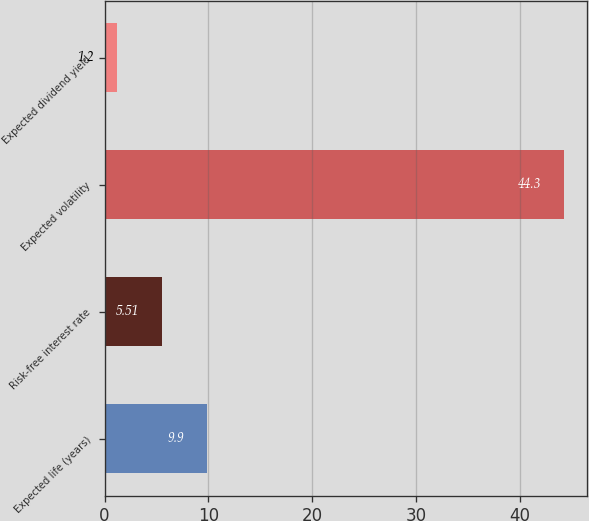Convert chart. <chart><loc_0><loc_0><loc_500><loc_500><bar_chart><fcel>Expected life (years)<fcel>Risk-free interest rate<fcel>Expected volatility<fcel>Expected dividend yield<nl><fcel>9.9<fcel>5.51<fcel>44.3<fcel>1.2<nl></chart> 